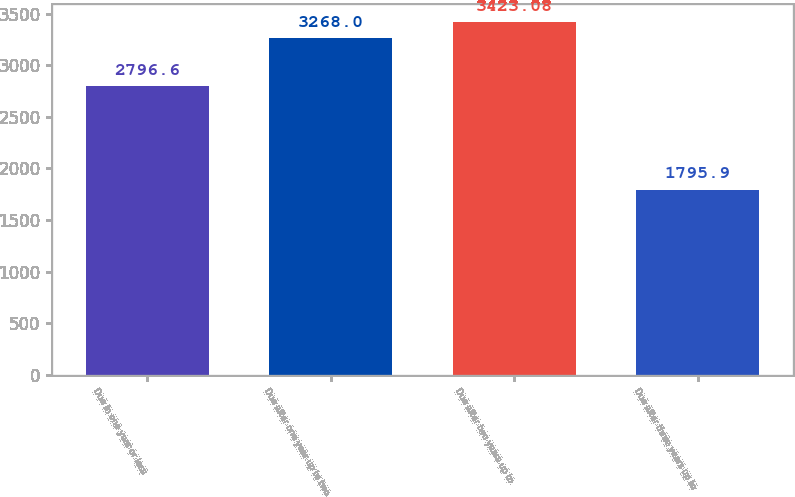<chart> <loc_0><loc_0><loc_500><loc_500><bar_chart><fcel>Due in one year or less<fcel>Due after one year up to two<fcel>Due after two years up to<fcel>Due after three years up to<nl><fcel>2796.6<fcel>3268<fcel>3423.08<fcel>1795.9<nl></chart> 